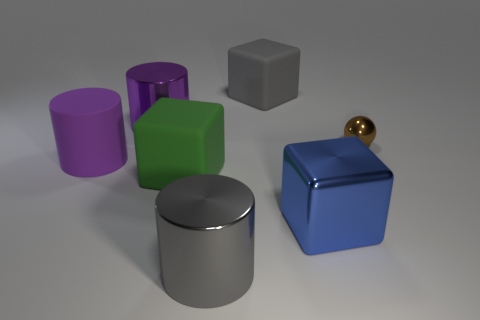Add 2 gray metallic objects. How many objects exist? 9 Subtract all cylinders. How many objects are left? 4 Add 6 big purple matte things. How many big purple matte things are left? 7 Add 4 large green objects. How many large green objects exist? 5 Subtract 0 brown cylinders. How many objects are left? 7 Subtract all tiny brown shiny things. Subtract all brown metal objects. How many objects are left? 5 